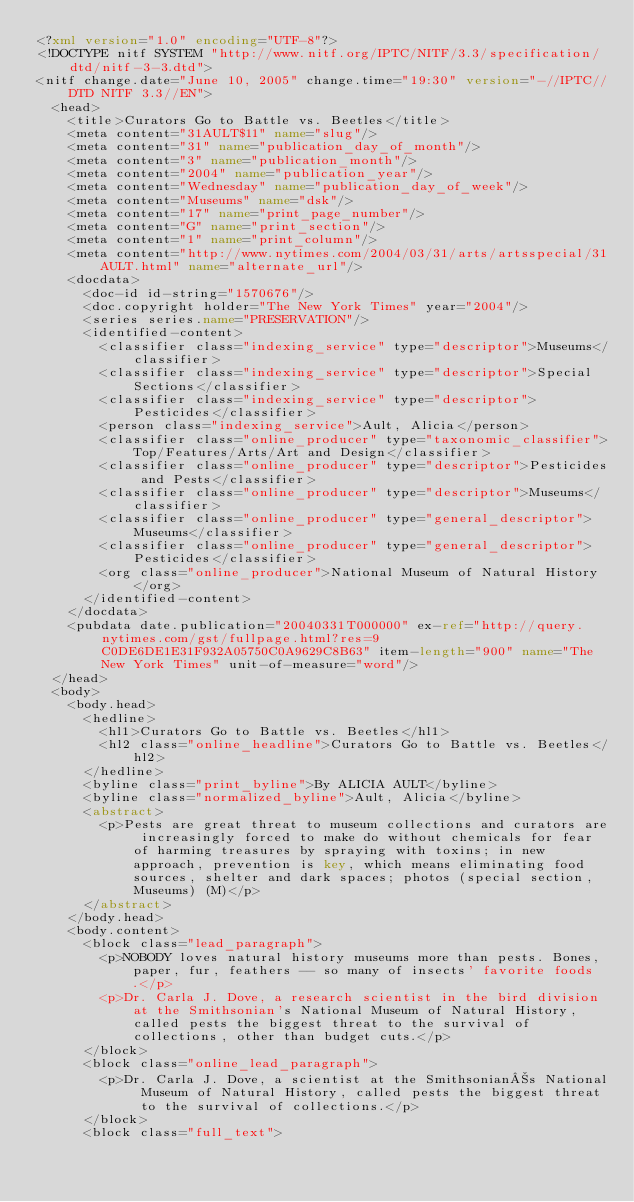<code> <loc_0><loc_0><loc_500><loc_500><_XML_><?xml version="1.0" encoding="UTF-8"?>
<!DOCTYPE nitf SYSTEM "http://www.nitf.org/IPTC/NITF/3.3/specification/dtd/nitf-3-3.dtd">
<nitf change.date="June 10, 2005" change.time="19:30" version="-//IPTC//DTD NITF 3.3//EN">
  <head>
    <title>Curators Go to Battle vs. Beetles</title>
    <meta content="31AULT$11" name="slug"/>
    <meta content="31" name="publication_day_of_month"/>
    <meta content="3" name="publication_month"/>
    <meta content="2004" name="publication_year"/>
    <meta content="Wednesday" name="publication_day_of_week"/>
    <meta content="Museums" name="dsk"/>
    <meta content="17" name="print_page_number"/>
    <meta content="G" name="print_section"/>
    <meta content="1" name="print_column"/>
    <meta content="http://www.nytimes.com/2004/03/31/arts/artsspecial/31AULT.html" name="alternate_url"/>
    <docdata>
      <doc-id id-string="1570676"/>
      <doc.copyright holder="The New York Times" year="2004"/>
      <series series.name="PRESERVATION"/>
      <identified-content>
        <classifier class="indexing_service" type="descriptor">Museums</classifier>
        <classifier class="indexing_service" type="descriptor">Special Sections</classifier>
        <classifier class="indexing_service" type="descriptor">Pesticides</classifier>
        <person class="indexing_service">Ault, Alicia</person>
        <classifier class="online_producer" type="taxonomic_classifier">Top/Features/Arts/Art and Design</classifier>
        <classifier class="online_producer" type="descriptor">Pesticides and Pests</classifier>
        <classifier class="online_producer" type="descriptor">Museums</classifier>
        <classifier class="online_producer" type="general_descriptor">Museums</classifier>
        <classifier class="online_producer" type="general_descriptor">Pesticides</classifier>
        <org class="online_producer">National Museum of Natural History</org>
      </identified-content>
    </docdata>
    <pubdata date.publication="20040331T000000" ex-ref="http://query.nytimes.com/gst/fullpage.html?res=9C0DE6DE1E31F932A05750C0A9629C8B63" item-length="900" name="The New York Times" unit-of-measure="word"/>
  </head>
  <body>
    <body.head>
      <hedline>
        <hl1>Curators Go to Battle vs. Beetles</hl1>
        <hl2 class="online_headline">Curators Go to Battle vs. Beetles</hl2>
      </hedline>
      <byline class="print_byline">By ALICIA AULT</byline>
      <byline class="normalized_byline">Ault, Alicia</byline>
      <abstract>
        <p>Pests are great threat to museum collections and curators are increasingly forced to make do without chemicals for fear of harming treasures by spraying with toxins; in new approach, prevention is key, which means eliminating food sources, shelter and dark spaces; photos (special section, Museums) (M)</p>
      </abstract>
    </body.head>
    <body.content>
      <block class="lead_paragraph">
        <p>NOBODY loves natural history museums more than pests. Bones, paper, fur, feathers -- so many of insects' favorite foods.</p>
        <p>Dr. Carla J. Dove, a research scientist in the bird division at the Smithsonian's National Museum of Natural History, called pests the biggest threat to the survival of collections, other than budget cuts.</p>
      </block>
      <block class="online_lead_paragraph">
        <p>Dr. Carla J. Dove, a scientist at the Smithsonians National Museum of Natural History, called pests the biggest threat to the survival of collections.</p>
      </block>
      <block class="full_text"></code> 